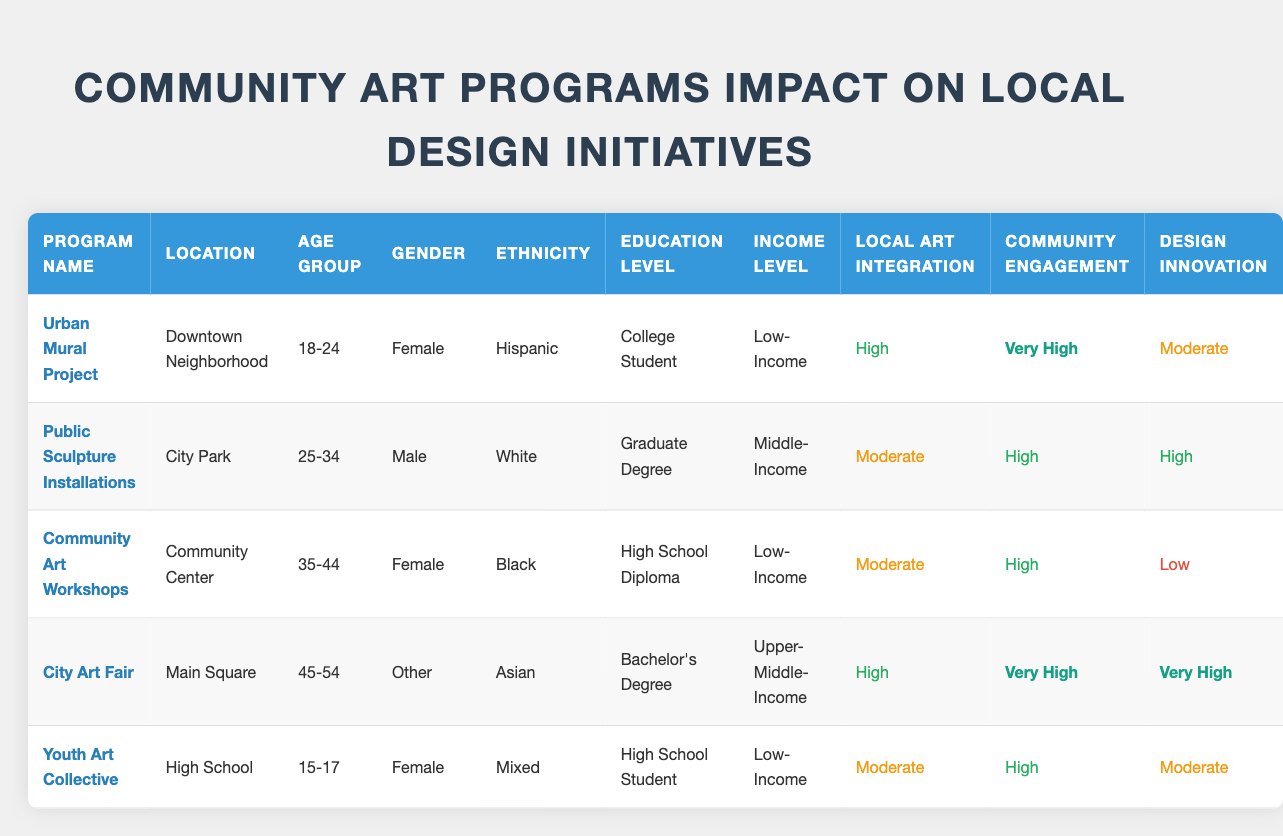What age group has the highest community engagement rating? The highest community engagement rating is "Very High." Upon examining the table, the "Urban Mural Project" and the "City Art Fair" both have a "Very High" community engagement. The age group for the Urban Mural Project is 18-24, while for the City Art Fair, it's 45-54. To answer the question, we identify the age group corresponding to the highest rating.
Answer: 18-24 and 45-54 Which program had the lowest design innovation impact? The design innovation ratings vary across five programs. The "Community Art Workshops" describe a low rating for design innovation. By locating the design innovation ratings in the table, we see that the only program with "Low" in design innovation is the Community Art Workshops, making it the program with the lowest impact.
Answer: Community Art Workshops What is the income level of participants involved in the City Art Fair? To find the income level of participants in a specific program, we refer to the "City Art Fair" row in the table. Looking closely, we see that the income level there is "Upper-Middle-Income." This provides the direct answer to the question without further calculation or reasoning.
Answer: Upper-Middle-Income Does the Public Sculpture Installations program involve low-income participants? We can refer to the table and find the "Public Sculpture Installations" row. The income level listed for this program is "Middle-Income." Therefore, the answer to this question is straightforward, as it directly derives from the participant demographic information.
Answer: No What is the combined number of participants from low-income programs with high community engagement? We will assess the programs that show a high community engagement rating and are classified under a low-income demographic. The "Urban Mural Project" has "Very High" community engagement and "Low-Income" status. The "Community Art Workshops" have a "High" engagement rating but also belong to "Low-Income." Hence, there are two programs fulfilling these criteria. Counting these, we find the total: 2 low-income programs with high engagement.
Answer: 2 